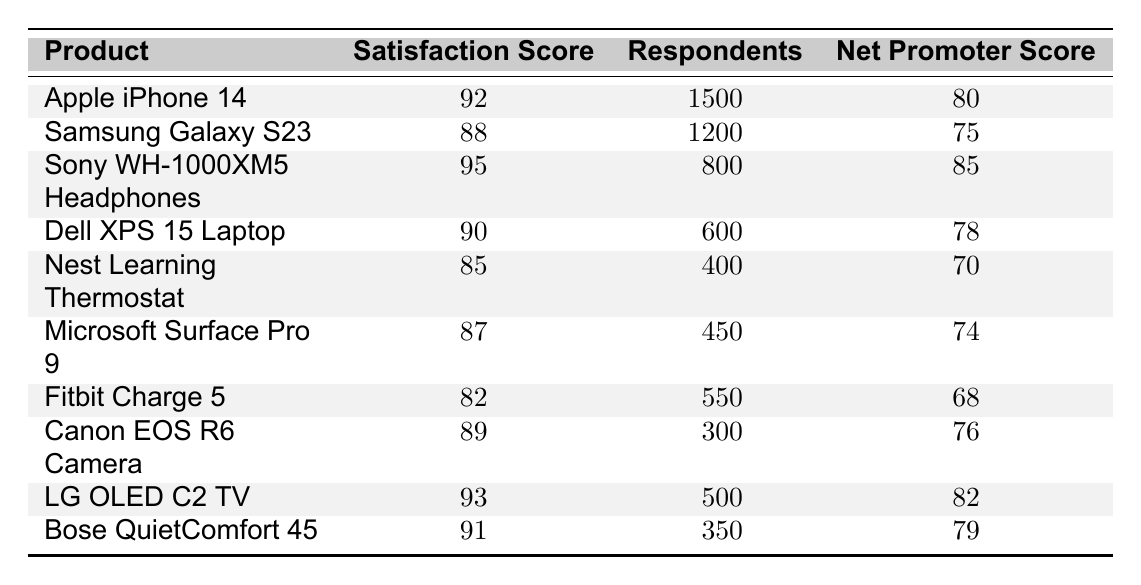What is the satisfaction score for the Samsung Galaxy S23? The Samsung Galaxy S23 has a satisfaction score listed in the table, which is 88.
Answer: 88 Which product has the highest satisfaction score? By reviewing the satisfaction scores in the table, the Sony WH-1000XM5 Headphones have the highest score, which is 95.
Answer: Sony WH-1000XM5 Headphones What is the Net Promoter Score for the Apple iPhone 14? The Net Promoter Score for the Apple iPhone 14 is shown in the table as 80.
Answer: 80 Calculate the average satisfaction score of all listed products. To find the average, we sum all satisfaction scores (92 + 88 + 95 + 90 + 85 + 87 + 82 + 89 + 93 + 91 = 910) and divide by the number of products (10), resulting in an average of 91.
Answer: 91 How many respondents gave feedback on the LG OLED C2 TV? The number of respondents for the LG OLED C2 TV is directly indicated in the table as 500.
Answer: 500 Is the satisfaction score of the Microsoft Surface Pro 9 greater than the average satisfaction score? The satisfaction score for the Microsoft Surface Pro 9 is 87. The average score is 91, so it is not greater than the average.
Answer: No Which two products have a Net Promoter Score of 80 or above? By reviewing the Net Promoter Scores, the products with scores of 80 or above are the Apple iPhone 14 (80) and the Sony WH-1000XM5 Headphones (85).
Answer: Apple iPhone 14 and Sony WH-1000XM5 Headphones What is the percentage of respondents who rated the Canon EOS R6 Camera compared to the total respondents? The total number of respondents across all products is 1500 + 1200 + 800 + 600 + 400 + 450 + 550 + 300 + 500 + 350 = 6100. The Canon EOS R6 Camera had 300 respondents, so the percentage is (300/6100) * 100 ≈ 4.92%.
Answer: Approximately 4.92% Is the satisfaction score of the Fitbit Charge 5 below the average satisfaction score? The average satisfaction score is 91 and the Fitbit Charge 5 score is 82, so it is indeed below the average.
Answer: Yes What is the difference between the highest and lowest satisfaction scores? The highest satisfaction score is 95 (Sony WH-1000XM5 Headphones) and the lowest is 82 (Fitbit Charge 5). The difference is 95 - 82 = 13.
Answer: 13 